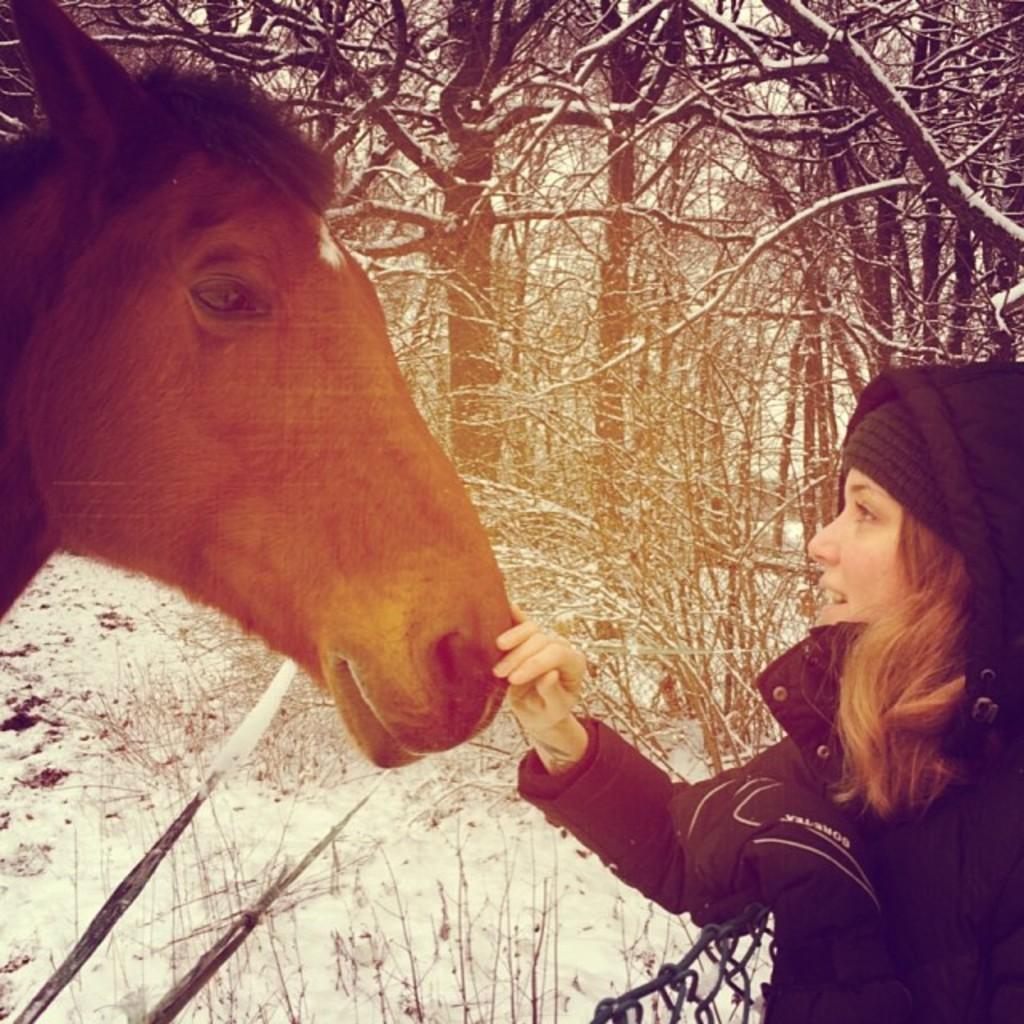What type of vegetation is present in the image? There are dry trees in the image. What animal can be seen in the image? There is a horse in the image. Are there any human figures in the image? Yes, there is a woman in the image. Where is the playground located in the image? There is no playground present in the image. How many kittens can be seen running around in the image? There are no kittens present in the image. 